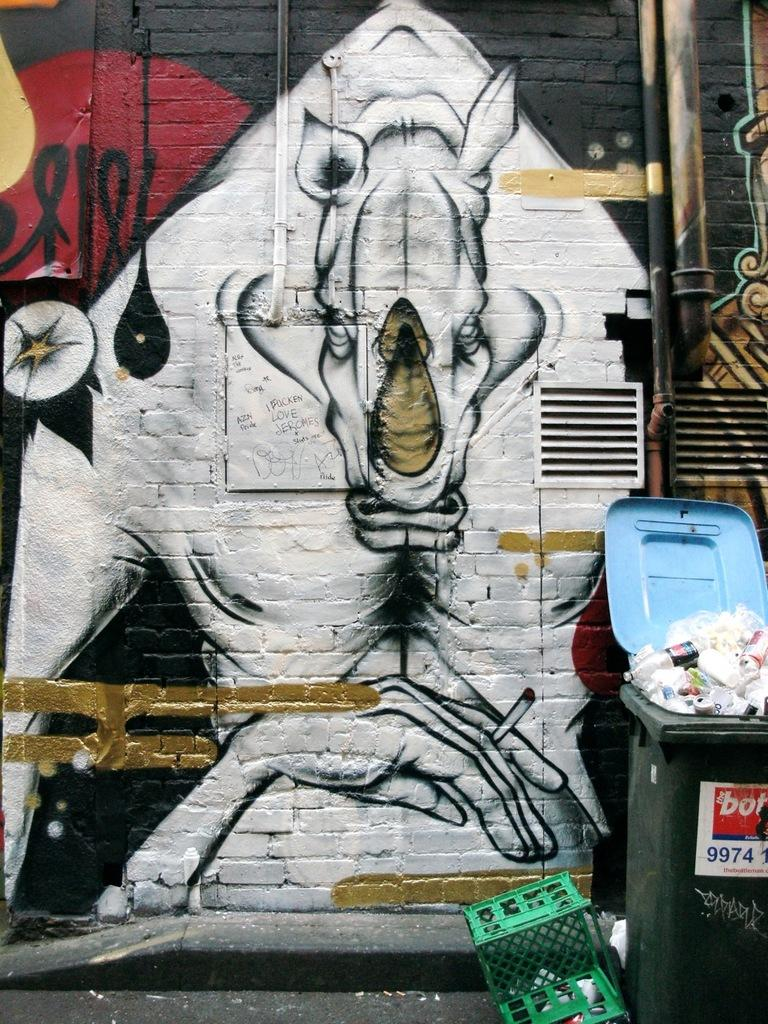<image>
Present a compact description of the photo's key features. A trashcan with a sticker that says The bot on it in front of a painting of a rhino on a wall. 